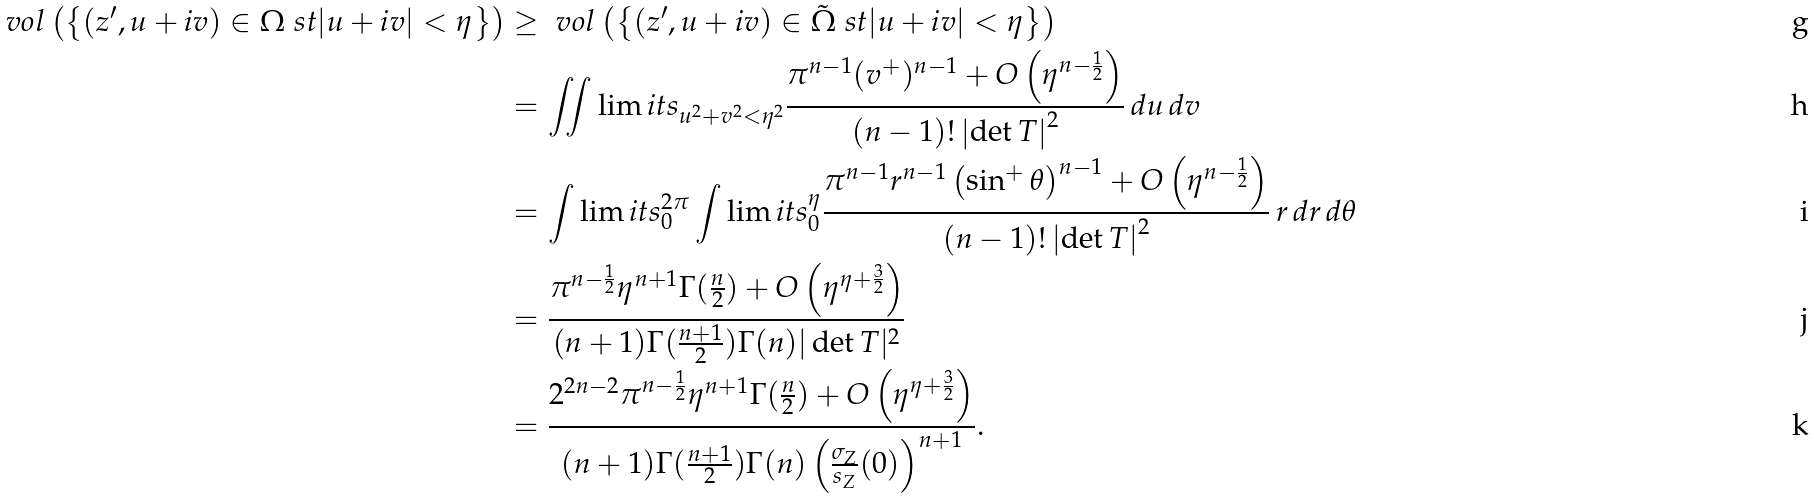Convert formula to latex. <formula><loc_0><loc_0><loc_500><loc_500>\ v o l \left ( \left \{ ( z ^ { \prime } , u + i v ) \in \Omega \ s t | u + i v | < \eta \right \} \right ) & \geq \ v o l \left ( \left \{ ( z ^ { \prime } , u + i v ) \in \tilde { \Omega } \ s t | u + i v | < \eta \right \} \right ) \\ & = \iint \lim i t s _ { u ^ { 2 } + v ^ { 2 } < \eta ^ { 2 } } \frac { \pi ^ { n - 1 } ( v ^ { + } ) ^ { n - 1 } + O \left ( \eta ^ { n - \frac { 1 } { 2 } } \right ) } { ( n - 1 ) ! \left | \det T \right | ^ { 2 } } \, d u \, d v \\ & = \int \lim i t s _ { 0 } ^ { 2 \pi } \int \lim i t s _ { 0 } ^ { \eta } \frac { \pi ^ { n - 1 } r ^ { n - 1 } \left ( \sin ^ { + } \theta \right ) ^ { n - 1 } + O \left ( \eta ^ { n - \frac { 1 } { 2 } } \right ) } { ( n - 1 ) ! \left | \det T \right | ^ { 2 } } \, r \, d r \, d \theta \\ & = \frac { \pi ^ { n - \frac { 1 } { 2 } } \eta ^ { n + 1 } \Gamma ( \frac { n } { 2 } ) + O \left ( \eta ^ { \eta + \frac { 3 } { 2 } } \right ) } { ( n + 1 ) \Gamma ( \frac { n + 1 } { 2 } ) \Gamma ( n ) | \det T | ^ { 2 } } \\ & = \frac { 2 ^ { 2 n - 2 } \pi ^ { n - \frac { 1 } { 2 } } \eta ^ { n + 1 } \Gamma ( \frac { n } { 2 } ) + O \left ( \eta ^ { \eta + \frac { 3 } { 2 } } \right ) } { ( n + 1 ) \Gamma ( \frac { n + 1 } { 2 } ) \Gamma ( n ) \left ( \frac { \sigma _ { Z } } { s _ { Z } } ( 0 ) \right ) ^ { n + 1 } } .</formula> 